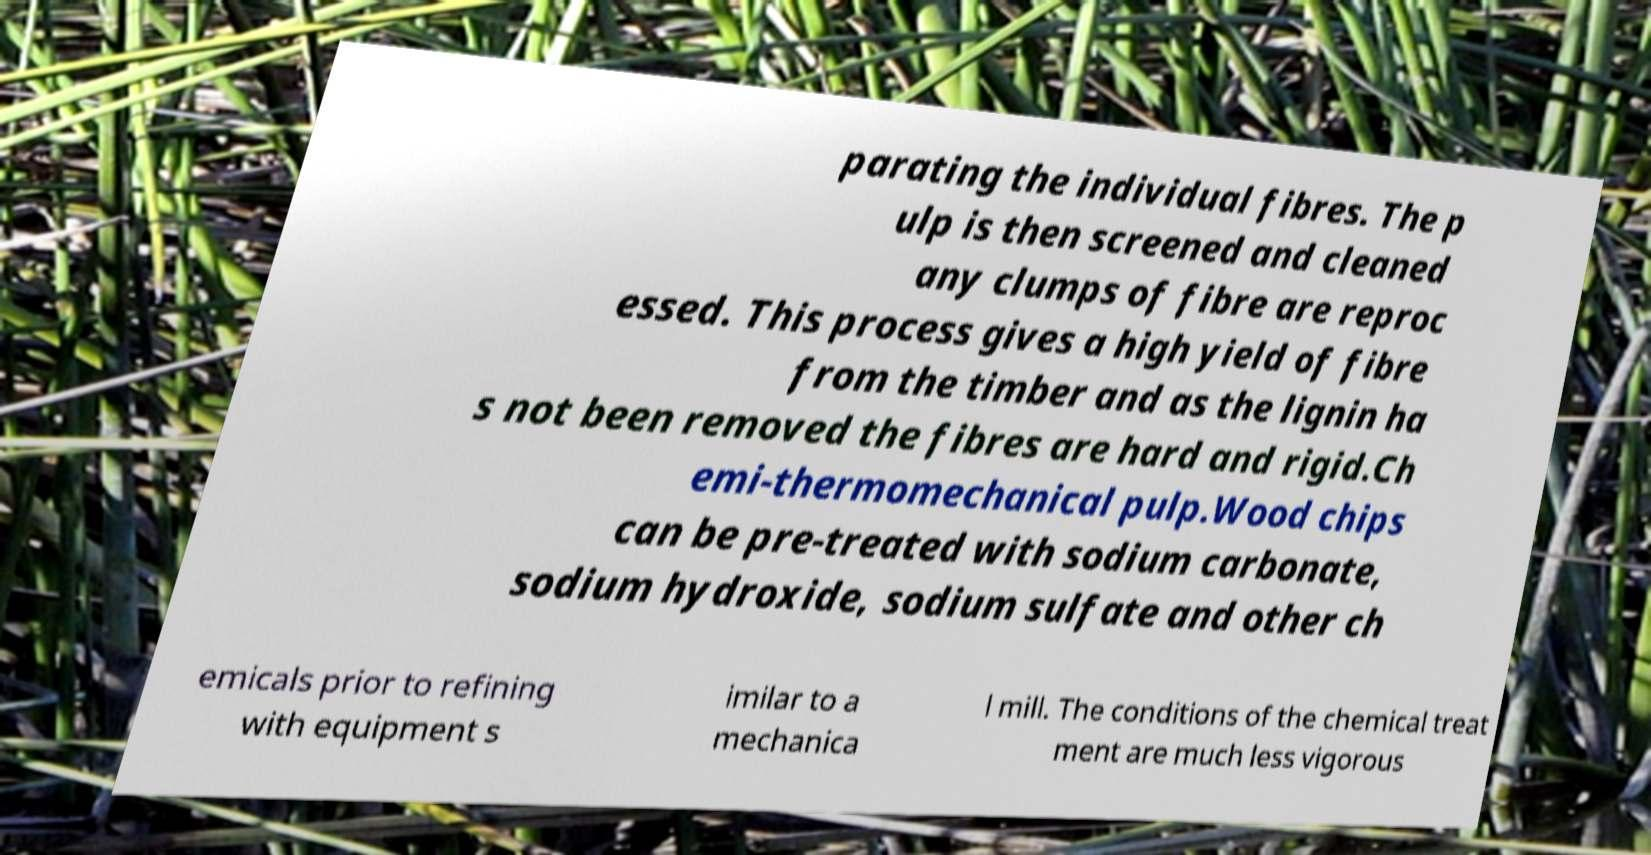Can you read and provide the text displayed in the image?This photo seems to have some interesting text. Can you extract and type it out for me? parating the individual fibres. The p ulp is then screened and cleaned any clumps of fibre are reproc essed. This process gives a high yield of fibre from the timber and as the lignin ha s not been removed the fibres are hard and rigid.Ch emi-thermomechanical pulp.Wood chips can be pre-treated with sodium carbonate, sodium hydroxide, sodium sulfate and other ch emicals prior to refining with equipment s imilar to a mechanica l mill. The conditions of the chemical treat ment are much less vigorous 